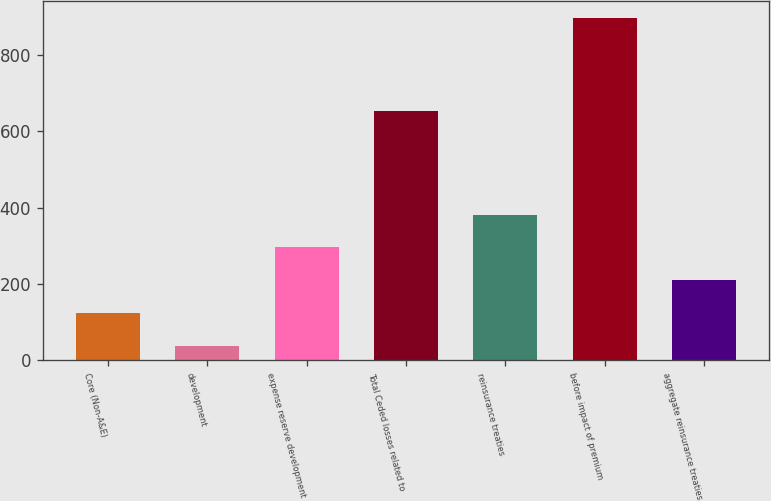<chart> <loc_0><loc_0><loc_500><loc_500><bar_chart><fcel>Core (Non-A&E)<fcel>development<fcel>expense reserve development<fcel>Total Ceded losses related to<fcel>reinsurance treaties<fcel>before impact of premium<fcel>aggregate reinsurance treaties<nl><fcel>123.9<fcel>38<fcel>295.7<fcel>652<fcel>381.6<fcel>897<fcel>209.8<nl></chart> 